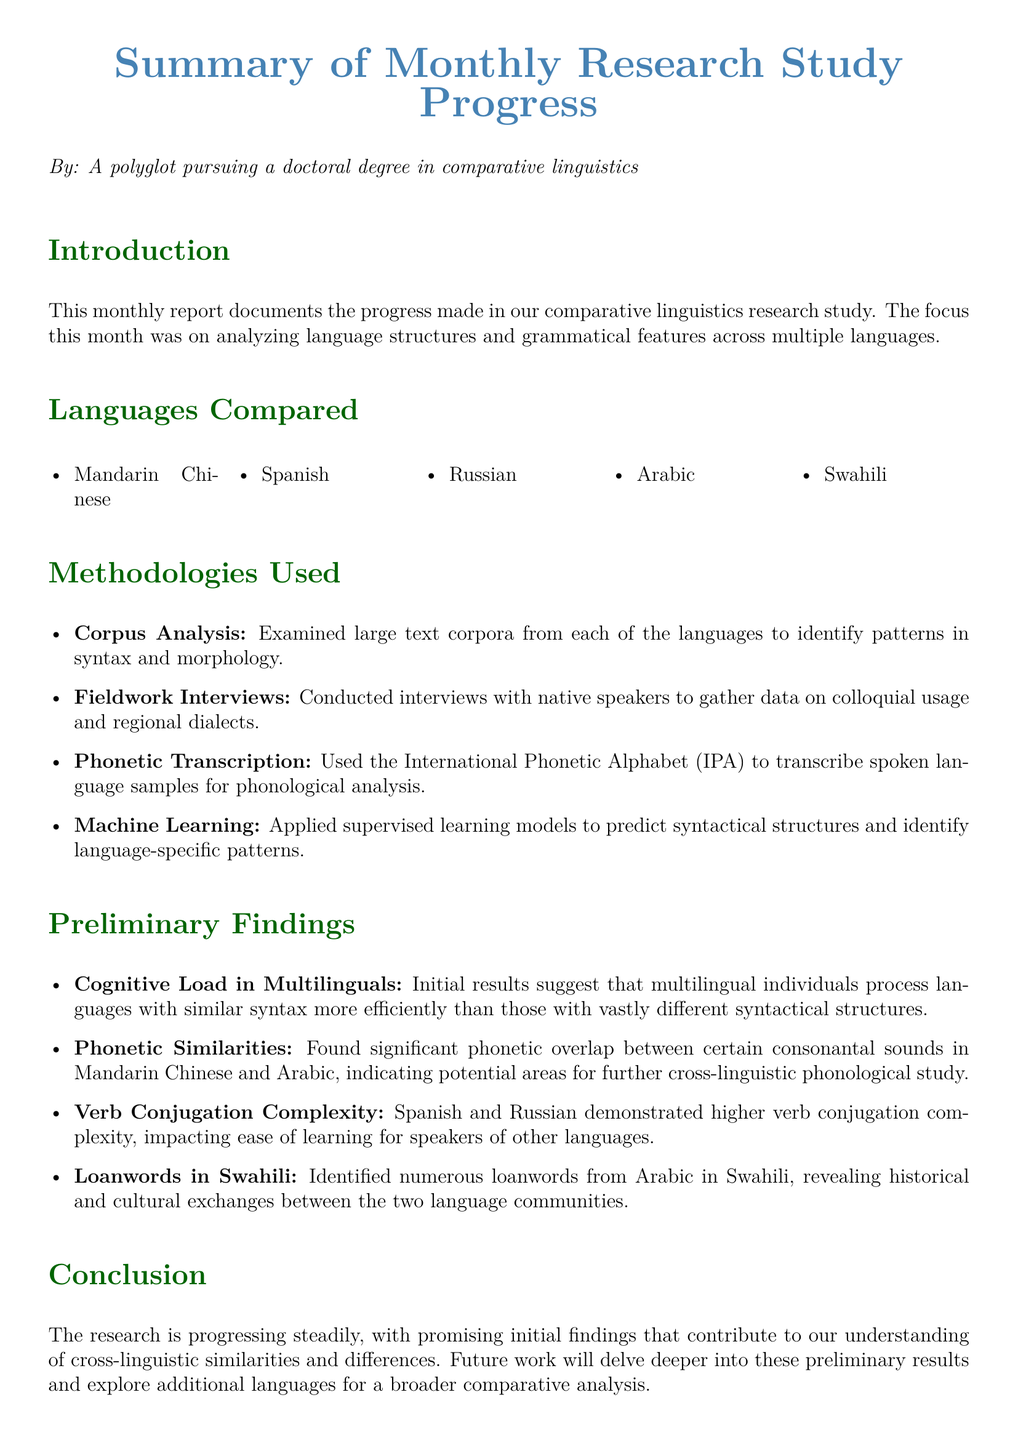What languages were compared in the study? The languages compared are listed in the "Languages Compared" section of the document.
Answer: Mandarin Chinese, Spanish, Russian, Arabic, Swahili What methodology involved examining large text corpora? The methodology section describes various methods used in the study.
Answer: Corpus Analysis Which two languages showed greater verb conjugation complexity? The "Preliminary Findings" section notes specific languages and their complexities.
Answer: Spanish and Russian What is one of the preliminary findings related to phonetics? The preliminary findings provide insights into phonetic overlaps explored in the research.
Answer: Significant phonetic overlap between certain consonantal sounds How many methodologies were used in the research study? The methodologies section enumerates the different approaches taken in the research.
Answer: Four What does the research suggest about multilingual individuals processing similar syntax? The findings indicate relationships between language processing and syntactical structure.
Answer: More efficiently Which language was found to have numerous loanwords from Arabic? The preliminary findings highlight specific languages and their linguistic interactions.
Answer: Swahili What type of transcription was used for phonological analysis? The methodology section specifies the tools used for phonological analysis.
Answer: International Phonetic Alphabet (IPA) What is the main focus of the research study? The introduction outlines the main objectives and areas of study for the monthly report.
Answer: Analyzing language structures and grammatical features 